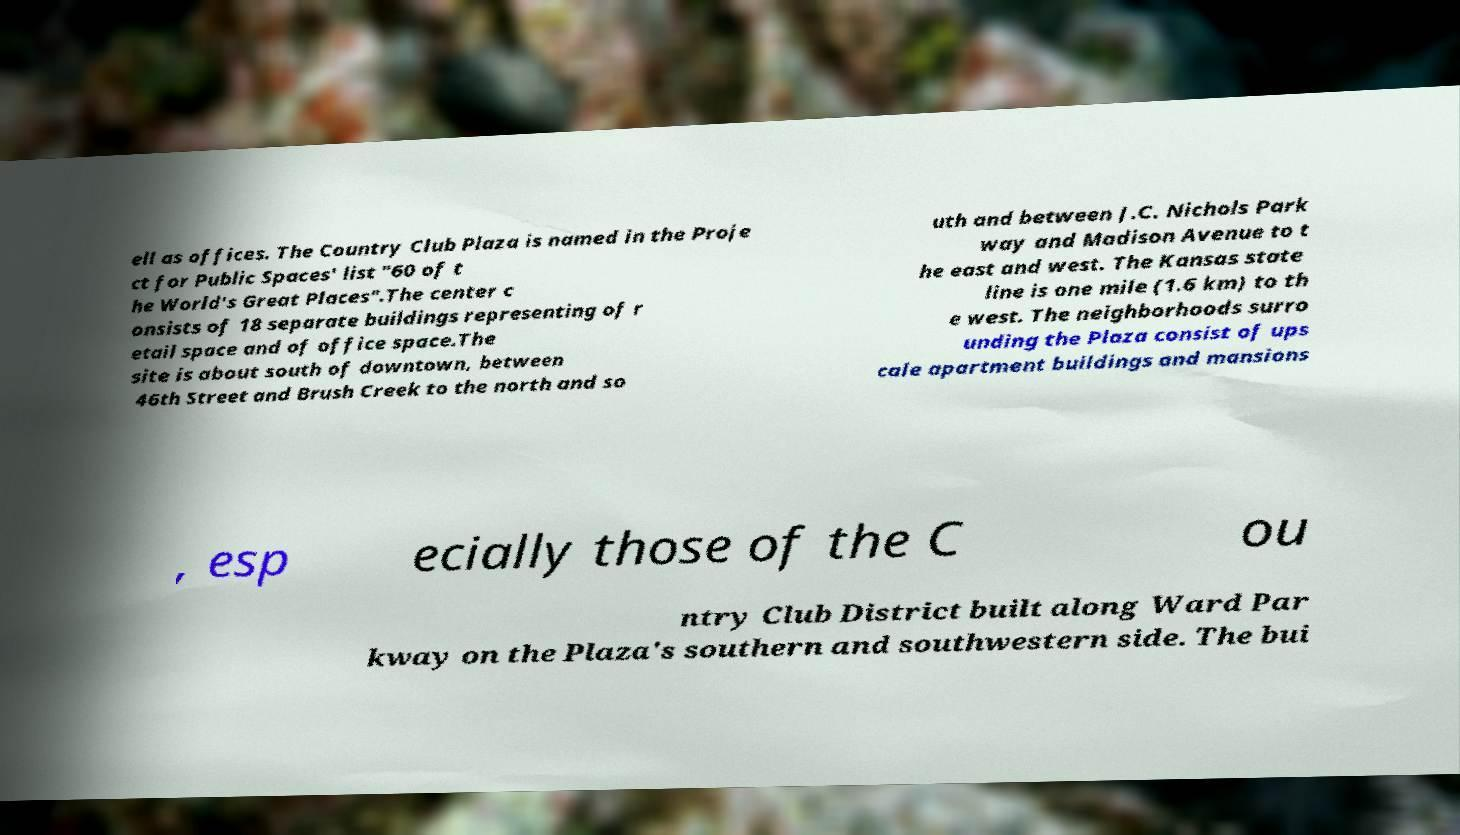Can you accurately transcribe the text from the provided image for me? ell as offices. The Country Club Plaza is named in the Proje ct for Public Spaces' list "60 of t he World's Great Places".The center c onsists of 18 separate buildings representing of r etail space and of office space.The site is about south of downtown, between 46th Street and Brush Creek to the north and so uth and between J.C. Nichols Park way and Madison Avenue to t he east and west. The Kansas state line is one mile (1.6 km) to th e west. The neighborhoods surro unding the Plaza consist of ups cale apartment buildings and mansions , esp ecially those of the C ou ntry Club District built along Ward Par kway on the Plaza's southern and southwestern side. The bui 